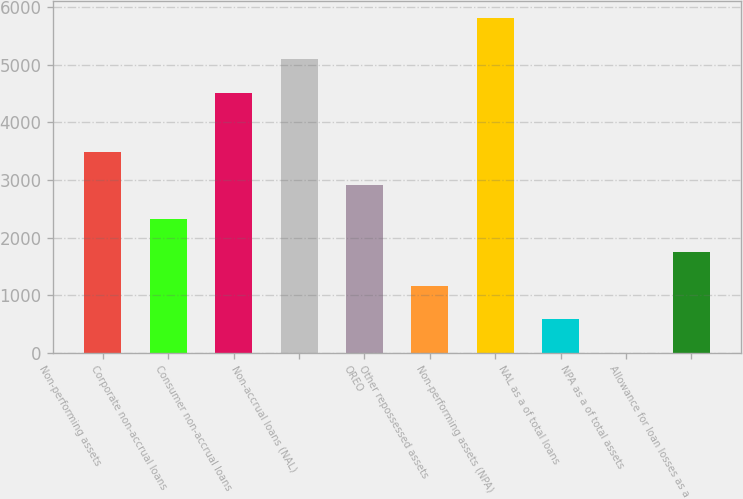<chart> <loc_0><loc_0><loc_500><loc_500><bar_chart><fcel>Non-performing assets<fcel>Corporate non-accrual loans<fcel>Consumer non-accrual loans<fcel>Non-accrual loans (NAL)<fcel>OREO<fcel>Other repossessed assets<fcel>Non-performing assets (NPA)<fcel>NAL as a of total loans<fcel>NPA as a of total assets<fcel>Allowance for loan losses as a<nl><fcel>3493.93<fcel>2329.39<fcel>4512<fcel>5094.27<fcel>2911.66<fcel>1164.85<fcel>5823<fcel>582.58<fcel>0.31<fcel>1747.12<nl></chart> 